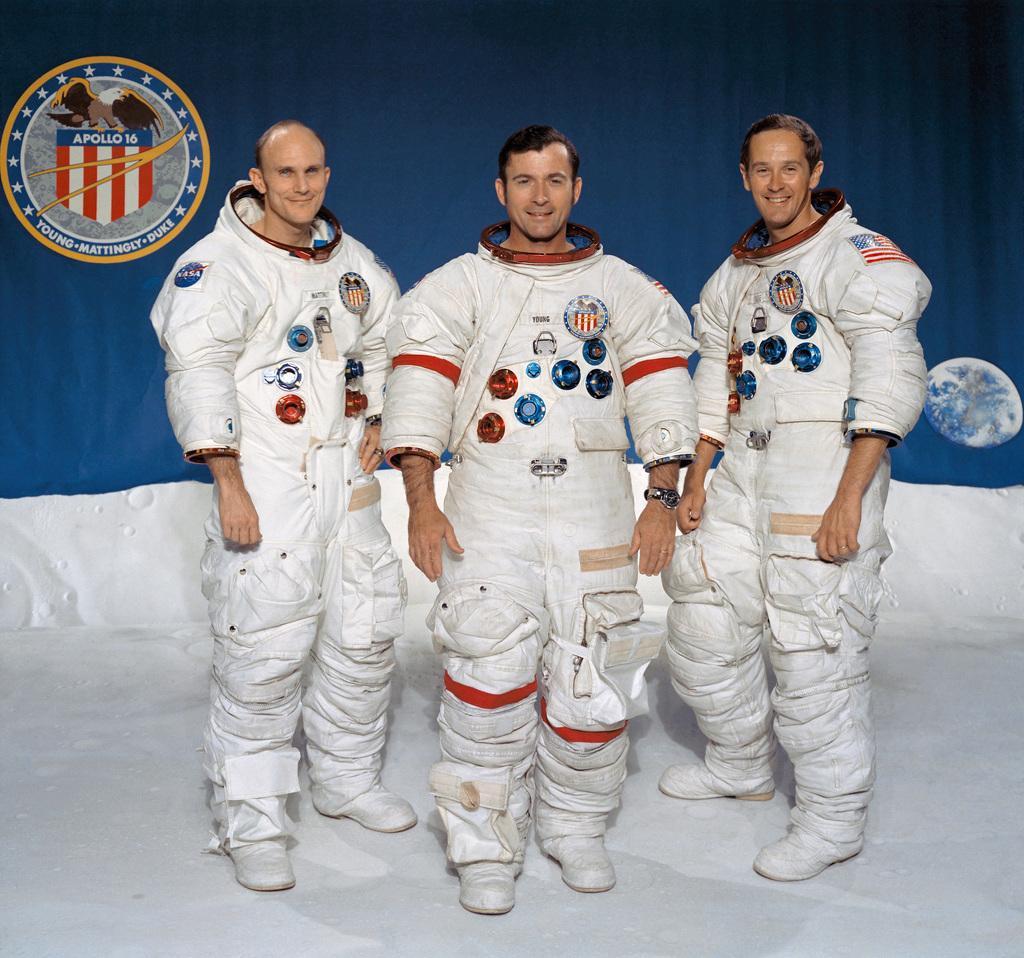How would you summarize this image in a sentence or two? In this image there are three persons standing on the floor. They are wearing astronaut dress. Behind them there is a poster having an emblem and an image of a moon are on it. 